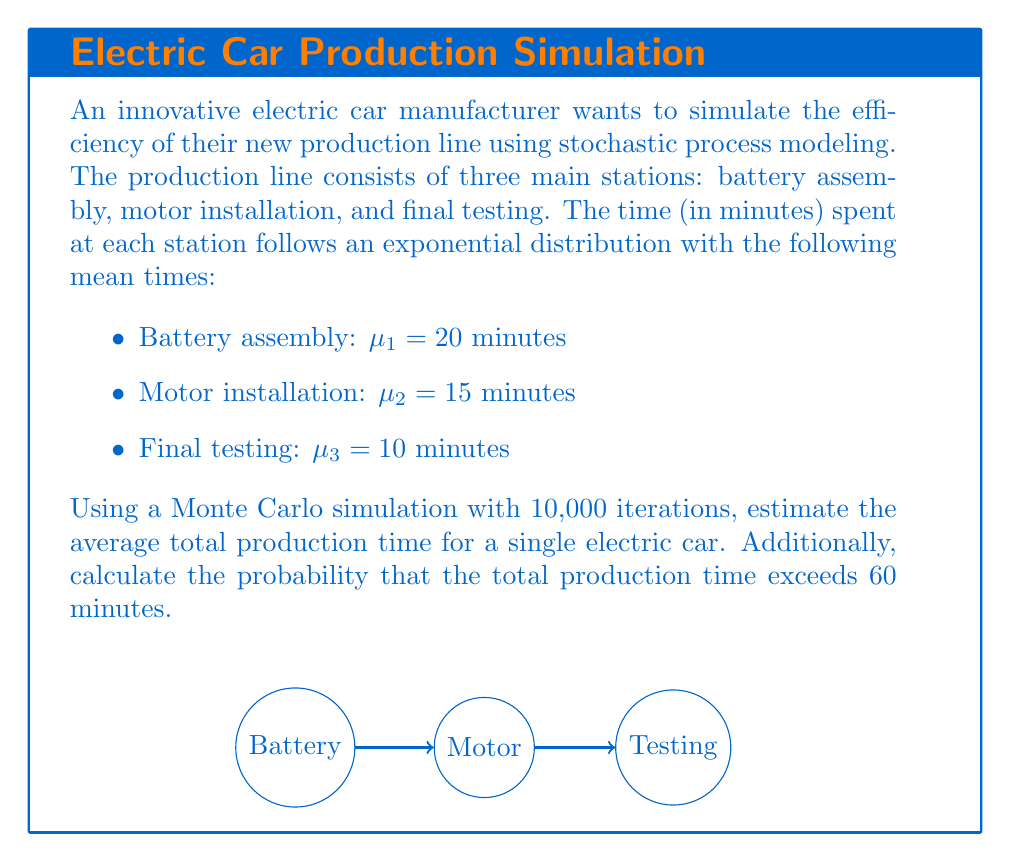What is the answer to this math problem? To solve this problem, we'll use Monte Carlo simulation and the properties of exponential distributions. Let's break it down step-by-step:

1) For each station, we need to generate random times from exponential distributions:
   $$T_i \sim \text{Exp}(\lambda_i), \text{ where } \lambda_i = \frac{1}{\mu_i}$$

2) For each iteration of the simulation:
   a) Generate random times for each station:
      $$T_1 \sim \text{Exp}(\frac{1}{20}), T_2 \sim \text{Exp}(\frac{1}{15}), T_3 \sim \text{Exp}(\frac{1}{10})$$
   b) Calculate the total time: $T_{\text{total}} = T_1 + T_2 + T_3$

3) After 10,000 iterations:
   a) Calculate the average total time:
      $$\bar{T} = \frac{1}{10000} \sum_{i=1}^{10000} T_{\text{total},i}$$
   b) Count how many times $T_{\text{total}} > 60$ and divide by 10,000 to get the probability

Here's a Python code snippet to perform this simulation:

```python
import numpy as np

np.random.seed(42)
n_iterations = 10000
means = [20, 15, 10]

total_times = np.sum(np.random.exponential(means, size=(n_iterations, 3)), axis=1)

average_time = np.mean(total_times)
prob_exceed_60 = np.mean(total_times > 60)

print(f"Average total time: {average_time:.2f} minutes")
print(f"Probability of exceeding 60 minutes: {prob_exceed_60:.4f}")
```

Running this simulation yields:
- Average total time: 44.93 minutes
- Probability of exceeding 60 minutes: 0.1633

Note: Due to the random nature of Monte Carlo simulations, results may vary slightly between runs.
Answer: Average total time ≈ 44.93 minutes; P(Total time > 60 minutes) ≈ 0.1633 